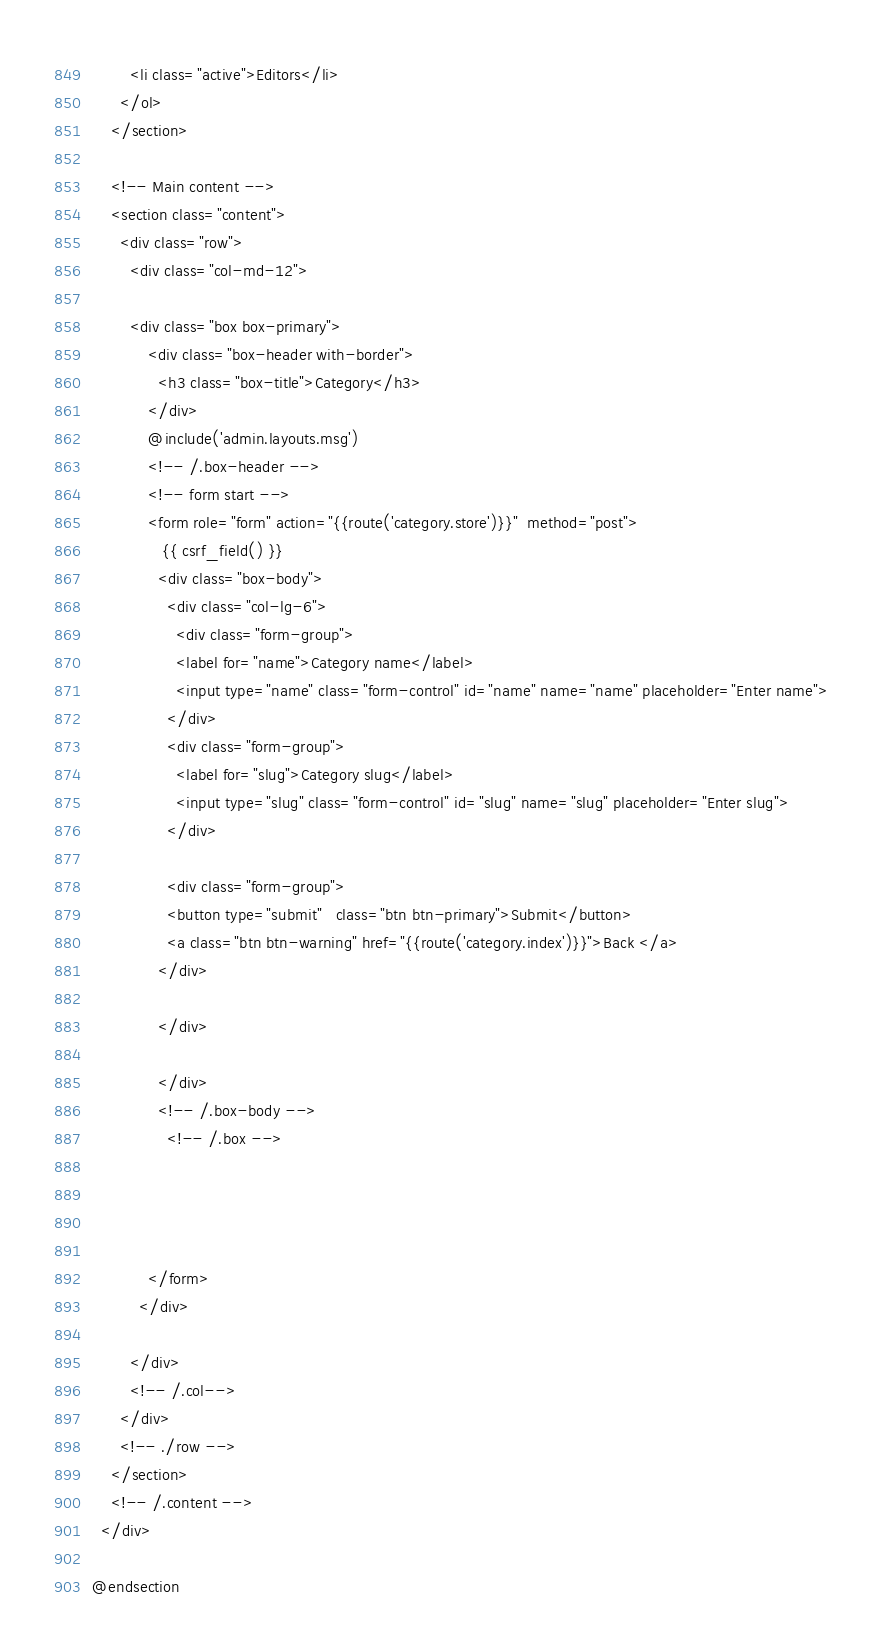Convert code to text. <code><loc_0><loc_0><loc_500><loc_500><_PHP_>        <li class="active">Editors</li>
      </ol>
    </section>

    <!-- Main content -->
    <section class="content">
      <div class="row">
        <div class="col-md-12">
      
        <div class="box box-primary">
            <div class="box-header with-border">
              <h3 class="box-title">Category</h3>
            </div>
            @include('admin.layouts.msg')
            <!-- /.box-header -->
            <!-- form start -->
            <form role="form" action="{{route('category.store')}}"  method="post">
               {{ csrf_field() }}
              <div class="box-body">
                <div class="col-lg-6">
                  <div class="form-group">
                  <label for="name">Category name</label>
                  <input type="name" class="form-control" id="name" name="name" placeholder="Enter name">
                </div>
                <div class="form-group">
                  <label for="slug">Category slug</label>
                  <input type="slug" class="form-control" id="slug" name="slug" placeholder="Enter slug">
                </div>

                <div class="form-group">
                <button type="submit"   class="btn btn-primary">Submit</button>
                <a class="btn btn-warning" href="{{route('category.index')}}">Back </a>
              </div>
                
              </div>    
              
              </div>
              <!-- /.box-body -->
                <!-- /.box -->

            
              

            </form>
          </div>
        
        </div>
        <!-- /.col-->
      </div>
      <!-- ./row -->
    </section>
    <!-- /.content -->
  </div>

@endsection</code> 